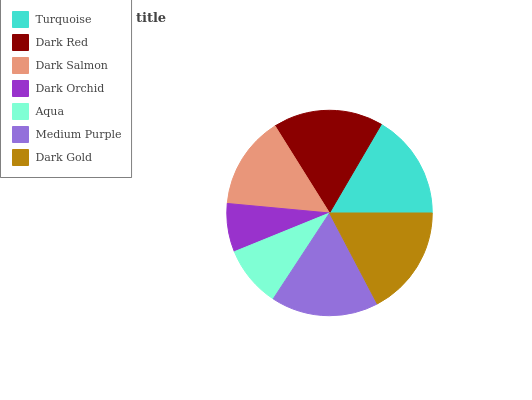Is Dark Orchid the minimum?
Answer yes or no. Yes. Is Dark Red the maximum?
Answer yes or no. Yes. Is Dark Salmon the minimum?
Answer yes or no. No. Is Dark Salmon the maximum?
Answer yes or no. No. Is Dark Red greater than Dark Salmon?
Answer yes or no. Yes. Is Dark Salmon less than Dark Red?
Answer yes or no. Yes. Is Dark Salmon greater than Dark Red?
Answer yes or no. No. Is Dark Red less than Dark Salmon?
Answer yes or no. No. Is Turquoise the high median?
Answer yes or no. Yes. Is Turquoise the low median?
Answer yes or no. Yes. Is Aqua the high median?
Answer yes or no. No. Is Dark Salmon the low median?
Answer yes or no. No. 